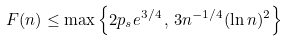Convert formula to latex. <formula><loc_0><loc_0><loc_500><loc_500>F ( n ) \leq \max \left \{ 2 p _ { s } e ^ { 3 / 4 } \, , \, 3 n ^ { - 1 / 4 } ( \ln n ) ^ { 2 } \right \}</formula> 